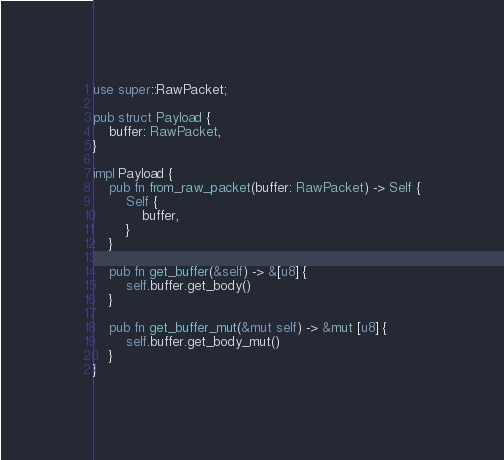<code> <loc_0><loc_0><loc_500><loc_500><_Rust_>use super::RawPacket;

pub struct Payload {
    buffer: RawPacket,
}

impl Payload {
    pub fn from_raw_packet(buffer: RawPacket) -> Self {
        Self {
            buffer,
        }
    }

    pub fn get_buffer(&self) -> &[u8] {
        self.buffer.get_body()
    }

    pub fn get_buffer_mut(&mut self) -> &mut [u8] {
        self.buffer.get_body_mut()
    }
}
</code> 